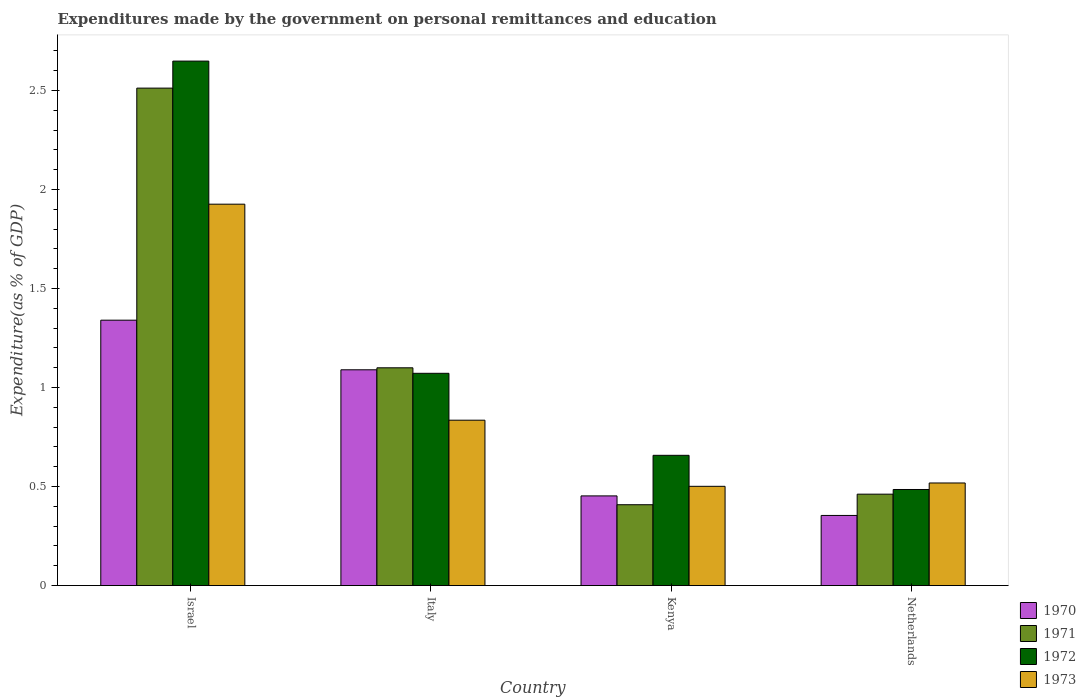How many different coloured bars are there?
Provide a succinct answer. 4. How many groups of bars are there?
Offer a terse response. 4. What is the label of the 3rd group of bars from the left?
Your answer should be very brief. Kenya. In how many cases, is the number of bars for a given country not equal to the number of legend labels?
Make the answer very short. 0. What is the expenditures made by the government on personal remittances and education in 1971 in Israel?
Offer a terse response. 2.51. Across all countries, what is the maximum expenditures made by the government on personal remittances and education in 1973?
Provide a succinct answer. 1.93. Across all countries, what is the minimum expenditures made by the government on personal remittances and education in 1971?
Keep it short and to the point. 0.41. In which country was the expenditures made by the government on personal remittances and education in 1972 minimum?
Make the answer very short. Netherlands. What is the total expenditures made by the government on personal remittances and education in 1971 in the graph?
Offer a terse response. 4.48. What is the difference between the expenditures made by the government on personal remittances and education in 1973 in Kenya and that in Netherlands?
Your answer should be very brief. -0.02. What is the difference between the expenditures made by the government on personal remittances and education in 1971 in Kenya and the expenditures made by the government on personal remittances and education in 1973 in Israel?
Keep it short and to the point. -1.52. What is the average expenditures made by the government on personal remittances and education in 1970 per country?
Give a very brief answer. 0.81. What is the difference between the expenditures made by the government on personal remittances and education of/in 1973 and expenditures made by the government on personal remittances and education of/in 1972 in Italy?
Your response must be concise. -0.24. In how many countries, is the expenditures made by the government on personal remittances and education in 1971 greater than 2.6 %?
Make the answer very short. 0. What is the ratio of the expenditures made by the government on personal remittances and education in 1970 in Italy to that in Kenya?
Offer a very short reply. 2.41. Is the expenditures made by the government on personal remittances and education in 1973 in Italy less than that in Kenya?
Offer a terse response. No. What is the difference between the highest and the second highest expenditures made by the government on personal remittances and education in 1972?
Your answer should be very brief. -0.41. What is the difference between the highest and the lowest expenditures made by the government on personal remittances and education in 1972?
Offer a very short reply. 2.16. Is it the case that in every country, the sum of the expenditures made by the government on personal remittances and education in 1972 and expenditures made by the government on personal remittances and education in 1971 is greater than the sum of expenditures made by the government on personal remittances and education in 1970 and expenditures made by the government on personal remittances and education in 1973?
Your answer should be compact. No. What does the 3rd bar from the left in Italy represents?
Give a very brief answer. 1972. What does the 4th bar from the right in Netherlands represents?
Provide a short and direct response. 1970. Is it the case that in every country, the sum of the expenditures made by the government on personal remittances and education in 1972 and expenditures made by the government on personal remittances and education in 1973 is greater than the expenditures made by the government on personal remittances and education in 1971?
Make the answer very short. Yes. Are all the bars in the graph horizontal?
Your answer should be compact. No. What is the difference between two consecutive major ticks on the Y-axis?
Provide a short and direct response. 0.5. Does the graph contain any zero values?
Your answer should be compact. No. Does the graph contain grids?
Give a very brief answer. No. Where does the legend appear in the graph?
Provide a short and direct response. Bottom right. How many legend labels are there?
Make the answer very short. 4. How are the legend labels stacked?
Provide a succinct answer. Vertical. What is the title of the graph?
Make the answer very short. Expenditures made by the government on personal remittances and education. Does "1984" appear as one of the legend labels in the graph?
Provide a succinct answer. No. What is the label or title of the X-axis?
Offer a very short reply. Country. What is the label or title of the Y-axis?
Provide a succinct answer. Expenditure(as % of GDP). What is the Expenditure(as % of GDP) of 1970 in Israel?
Offer a terse response. 1.34. What is the Expenditure(as % of GDP) in 1971 in Israel?
Provide a succinct answer. 2.51. What is the Expenditure(as % of GDP) of 1972 in Israel?
Offer a very short reply. 2.65. What is the Expenditure(as % of GDP) in 1973 in Israel?
Ensure brevity in your answer.  1.93. What is the Expenditure(as % of GDP) of 1970 in Italy?
Make the answer very short. 1.09. What is the Expenditure(as % of GDP) in 1971 in Italy?
Keep it short and to the point. 1.1. What is the Expenditure(as % of GDP) of 1972 in Italy?
Give a very brief answer. 1.07. What is the Expenditure(as % of GDP) of 1973 in Italy?
Ensure brevity in your answer.  0.84. What is the Expenditure(as % of GDP) in 1970 in Kenya?
Keep it short and to the point. 0.45. What is the Expenditure(as % of GDP) of 1971 in Kenya?
Offer a terse response. 0.41. What is the Expenditure(as % of GDP) in 1972 in Kenya?
Provide a short and direct response. 0.66. What is the Expenditure(as % of GDP) in 1973 in Kenya?
Provide a succinct answer. 0.5. What is the Expenditure(as % of GDP) in 1970 in Netherlands?
Make the answer very short. 0.35. What is the Expenditure(as % of GDP) in 1971 in Netherlands?
Keep it short and to the point. 0.46. What is the Expenditure(as % of GDP) in 1972 in Netherlands?
Ensure brevity in your answer.  0.49. What is the Expenditure(as % of GDP) of 1973 in Netherlands?
Provide a succinct answer. 0.52. Across all countries, what is the maximum Expenditure(as % of GDP) of 1970?
Offer a terse response. 1.34. Across all countries, what is the maximum Expenditure(as % of GDP) in 1971?
Offer a very short reply. 2.51. Across all countries, what is the maximum Expenditure(as % of GDP) of 1972?
Your response must be concise. 2.65. Across all countries, what is the maximum Expenditure(as % of GDP) of 1973?
Ensure brevity in your answer.  1.93. Across all countries, what is the minimum Expenditure(as % of GDP) of 1970?
Provide a short and direct response. 0.35. Across all countries, what is the minimum Expenditure(as % of GDP) of 1971?
Ensure brevity in your answer.  0.41. Across all countries, what is the minimum Expenditure(as % of GDP) of 1972?
Your answer should be compact. 0.49. Across all countries, what is the minimum Expenditure(as % of GDP) of 1973?
Keep it short and to the point. 0.5. What is the total Expenditure(as % of GDP) in 1970 in the graph?
Keep it short and to the point. 3.24. What is the total Expenditure(as % of GDP) in 1971 in the graph?
Offer a terse response. 4.48. What is the total Expenditure(as % of GDP) of 1972 in the graph?
Your response must be concise. 4.86. What is the total Expenditure(as % of GDP) in 1973 in the graph?
Provide a short and direct response. 3.78. What is the difference between the Expenditure(as % of GDP) of 1970 in Israel and that in Italy?
Offer a terse response. 0.25. What is the difference between the Expenditure(as % of GDP) of 1971 in Israel and that in Italy?
Offer a terse response. 1.41. What is the difference between the Expenditure(as % of GDP) of 1972 in Israel and that in Italy?
Your answer should be compact. 1.58. What is the difference between the Expenditure(as % of GDP) in 1970 in Israel and that in Kenya?
Offer a very short reply. 0.89. What is the difference between the Expenditure(as % of GDP) in 1971 in Israel and that in Kenya?
Give a very brief answer. 2.1. What is the difference between the Expenditure(as % of GDP) in 1972 in Israel and that in Kenya?
Your response must be concise. 1.99. What is the difference between the Expenditure(as % of GDP) of 1973 in Israel and that in Kenya?
Ensure brevity in your answer.  1.42. What is the difference between the Expenditure(as % of GDP) of 1970 in Israel and that in Netherlands?
Ensure brevity in your answer.  0.99. What is the difference between the Expenditure(as % of GDP) in 1971 in Israel and that in Netherlands?
Give a very brief answer. 2.05. What is the difference between the Expenditure(as % of GDP) of 1972 in Israel and that in Netherlands?
Offer a very short reply. 2.16. What is the difference between the Expenditure(as % of GDP) of 1973 in Israel and that in Netherlands?
Offer a very short reply. 1.41. What is the difference between the Expenditure(as % of GDP) of 1970 in Italy and that in Kenya?
Offer a terse response. 0.64. What is the difference between the Expenditure(as % of GDP) of 1971 in Italy and that in Kenya?
Offer a very short reply. 0.69. What is the difference between the Expenditure(as % of GDP) in 1972 in Italy and that in Kenya?
Keep it short and to the point. 0.41. What is the difference between the Expenditure(as % of GDP) in 1973 in Italy and that in Kenya?
Offer a very short reply. 0.33. What is the difference between the Expenditure(as % of GDP) in 1970 in Italy and that in Netherlands?
Offer a terse response. 0.74. What is the difference between the Expenditure(as % of GDP) of 1971 in Italy and that in Netherlands?
Provide a succinct answer. 0.64. What is the difference between the Expenditure(as % of GDP) of 1972 in Italy and that in Netherlands?
Your response must be concise. 0.59. What is the difference between the Expenditure(as % of GDP) of 1973 in Italy and that in Netherlands?
Ensure brevity in your answer.  0.32. What is the difference between the Expenditure(as % of GDP) in 1970 in Kenya and that in Netherlands?
Your response must be concise. 0.1. What is the difference between the Expenditure(as % of GDP) in 1971 in Kenya and that in Netherlands?
Offer a very short reply. -0.05. What is the difference between the Expenditure(as % of GDP) in 1972 in Kenya and that in Netherlands?
Keep it short and to the point. 0.17. What is the difference between the Expenditure(as % of GDP) of 1973 in Kenya and that in Netherlands?
Give a very brief answer. -0.02. What is the difference between the Expenditure(as % of GDP) of 1970 in Israel and the Expenditure(as % of GDP) of 1971 in Italy?
Make the answer very short. 0.24. What is the difference between the Expenditure(as % of GDP) of 1970 in Israel and the Expenditure(as % of GDP) of 1972 in Italy?
Make the answer very short. 0.27. What is the difference between the Expenditure(as % of GDP) of 1970 in Israel and the Expenditure(as % of GDP) of 1973 in Italy?
Offer a very short reply. 0.51. What is the difference between the Expenditure(as % of GDP) in 1971 in Israel and the Expenditure(as % of GDP) in 1972 in Italy?
Your answer should be compact. 1.44. What is the difference between the Expenditure(as % of GDP) of 1971 in Israel and the Expenditure(as % of GDP) of 1973 in Italy?
Offer a very short reply. 1.68. What is the difference between the Expenditure(as % of GDP) of 1972 in Israel and the Expenditure(as % of GDP) of 1973 in Italy?
Give a very brief answer. 1.81. What is the difference between the Expenditure(as % of GDP) in 1970 in Israel and the Expenditure(as % of GDP) in 1971 in Kenya?
Offer a very short reply. 0.93. What is the difference between the Expenditure(as % of GDP) in 1970 in Israel and the Expenditure(as % of GDP) in 1972 in Kenya?
Keep it short and to the point. 0.68. What is the difference between the Expenditure(as % of GDP) in 1970 in Israel and the Expenditure(as % of GDP) in 1973 in Kenya?
Provide a short and direct response. 0.84. What is the difference between the Expenditure(as % of GDP) of 1971 in Israel and the Expenditure(as % of GDP) of 1972 in Kenya?
Provide a succinct answer. 1.85. What is the difference between the Expenditure(as % of GDP) of 1971 in Israel and the Expenditure(as % of GDP) of 1973 in Kenya?
Your response must be concise. 2.01. What is the difference between the Expenditure(as % of GDP) of 1972 in Israel and the Expenditure(as % of GDP) of 1973 in Kenya?
Provide a short and direct response. 2.15. What is the difference between the Expenditure(as % of GDP) of 1970 in Israel and the Expenditure(as % of GDP) of 1971 in Netherlands?
Provide a succinct answer. 0.88. What is the difference between the Expenditure(as % of GDP) in 1970 in Israel and the Expenditure(as % of GDP) in 1972 in Netherlands?
Make the answer very short. 0.85. What is the difference between the Expenditure(as % of GDP) of 1970 in Israel and the Expenditure(as % of GDP) of 1973 in Netherlands?
Offer a terse response. 0.82. What is the difference between the Expenditure(as % of GDP) in 1971 in Israel and the Expenditure(as % of GDP) in 1972 in Netherlands?
Offer a very short reply. 2.03. What is the difference between the Expenditure(as % of GDP) of 1971 in Israel and the Expenditure(as % of GDP) of 1973 in Netherlands?
Offer a terse response. 1.99. What is the difference between the Expenditure(as % of GDP) in 1972 in Israel and the Expenditure(as % of GDP) in 1973 in Netherlands?
Offer a terse response. 2.13. What is the difference between the Expenditure(as % of GDP) in 1970 in Italy and the Expenditure(as % of GDP) in 1971 in Kenya?
Provide a succinct answer. 0.68. What is the difference between the Expenditure(as % of GDP) in 1970 in Italy and the Expenditure(as % of GDP) in 1972 in Kenya?
Keep it short and to the point. 0.43. What is the difference between the Expenditure(as % of GDP) of 1970 in Italy and the Expenditure(as % of GDP) of 1973 in Kenya?
Your answer should be very brief. 0.59. What is the difference between the Expenditure(as % of GDP) in 1971 in Italy and the Expenditure(as % of GDP) in 1972 in Kenya?
Offer a very short reply. 0.44. What is the difference between the Expenditure(as % of GDP) of 1971 in Italy and the Expenditure(as % of GDP) of 1973 in Kenya?
Ensure brevity in your answer.  0.6. What is the difference between the Expenditure(as % of GDP) of 1972 in Italy and the Expenditure(as % of GDP) of 1973 in Kenya?
Give a very brief answer. 0.57. What is the difference between the Expenditure(as % of GDP) of 1970 in Italy and the Expenditure(as % of GDP) of 1971 in Netherlands?
Ensure brevity in your answer.  0.63. What is the difference between the Expenditure(as % of GDP) of 1970 in Italy and the Expenditure(as % of GDP) of 1972 in Netherlands?
Provide a short and direct response. 0.6. What is the difference between the Expenditure(as % of GDP) of 1970 in Italy and the Expenditure(as % of GDP) of 1973 in Netherlands?
Make the answer very short. 0.57. What is the difference between the Expenditure(as % of GDP) of 1971 in Italy and the Expenditure(as % of GDP) of 1972 in Netherlands?
Keep it short and to the point. 0.61. What is the difference between the Expenditure(as % of GDP) of 1971 in Italy and the Expenditure(as % of GDP) of 1973 in Netherlands?
Give a very brief answer. 0.58. What is the difference between the Expenditure(as % of GDP) in 1972 in Italy and the Expenditure(as % of GDP) in 1973 in Netherlands?
Give a very brief answer. 0.55. What is the difference between the Expenditure(as % of GDP) of 1970 in Kenya and the Expenditure(as % of GDP) of 1971 in Netherlands?
Provide a succinct answer. -0.01. What is the difference between the Expenditure(as % of GDP) of 1970 in Kenya and the Expenditure(as % of GDP) of 1972 in Netherlands?
Give a very brief answer. -0.03. What is the difference between the Expenditure(as % of GDP) of 1970 in Kenya and the Expenditure(as % of GDP) of 1973 in Netherlands?
Your answer should be very brief. -0.07. What is the difference between the Expenditure(as % of GDP) of 1971 in Kenya and the Expenditure(as % of GDP) of 1972 in Netherlands?
Offer a very short reply. -0.08. What is the difference between the Expenditure(as % of GDP) in 1971 in Kenya and the Expenditure(as % of GDP) in 1973 in Netherlands?
Your answer should be very brief. -0.11. What is the difference between the Expenditure(as % of GDP) in 1972 in Kenya and the Expenditure(as % of GDP) in 1973 in Netherlands?
Your response must be concise. 0.14. What is the average Expenditure(as % of GDP) in 1970 per country?
Make the answer very short. 0.81. What is the average Expenditure(as % of GDP) in 1971 per country?
Provide a succinct answer. 1.12. What is the average Expenditure(as % of GDP) in 1972 per country?
Give a very brief answer. 1.22. What is the average Expenditure(as % of GDP) of 1973 per country?
Offer a terse response. 0.95. What is the difference between the Expenditure(as % of GDP) of 1970 and Expenditure(as % of GDP) of 1971 in Israel?
Your answer should be compact. -1.17. What is the difference between the Expenditure(as % of GDP) of 1970 and Expenditure(as % of GDP) of 1972 in Israel?
Offer a terse response. -1.31. What is the difference between the Expenditure(as % of GDP) of 1970 and Expenditure(as % of GDP) of 1973 in Israel?
Your response must be concise. -0.59. What is the difference between the Expenditure(as % of GDP) of 1971 and Expenditure(as % of GDP) of 1972 in Israel?
Offer a very short reply. -0.14. What is the difference between the Expenditure(as % of GDP) in 1971 and Expenditure(as % of GDP) in 1973 in Israel?
Give a very brief answer. 0.59. What is the difference between the Expenditure(as % of GDP) in 1972 and Expenditure(as % of GDP) in 1973 in Israel?
Offer a terse response. 0.72. What is the difference between the Expenditure(as % of GDP) of 1970 and Expenditure(as % of GDP) of 1971 in Italy?
Provide a succinct answer. -0.01. What is the difference between the Expenditure(as % of GDP) of 1970 and Expenditure(as % of GDP) of 1972 in Italy?
Give a very brief answer. 0.02. What is the difference between the Expenditure(as % of GDP) in 1970 and Expenditure(as % of GDP) in 1973 in Italy?
Give a very brief answer. 0.25. What is the difference between the Expenditure(as % of GDP) of 1971 and Expenditure(as % of GDP) of 1972 in Italy?
Your answer should be very brief. 0.03. What is the difference between the Expenditure(as % of GDP) of 1971 and Expenditure(as % of GDP) of 1973 in Italy?
Offer a terse response. 0.26. What is the difference between the Expenditure(as % of GDP) in 1972 and Expenditure(as % of GDP) in 1973 in Italy?
Provide a short and direct response. 0.24. What is the difference between the Expenditure(as % of GDP) of 1970 and Expenditure(as % of GDP) of 1971 in Kenya?
Offer a very short reply. 0.04. What is the difference between the Expenditure(as % of GDP) of 1970 and Expenditure(as % of GDP) of 1972 in Kenya?
Offer a terse response. -0.2. What is the difference between the Expenditure(as % of GDP) in 1970 and Expenditure(as % of GDP) in 1973 in Kenya?
Offer a very short reply. -0.05. What is the difference between the Expenditure(as % of GDP) in 1971 and Expenditure(as % of GDP) in 1972 in Kenya?
Offer a very short reply. -0.25. What is the difference between the Expenditure(as % of GDP) of 1971 and Expenditure(as % of GDP) of 1973 in Kenya?
Your answer should be compact. -0.09. What is the difference between the Expenditure(as % of GDP) of 1972 and Expenditure(as % of GDP) of 1973 in Kenya?
Make the answer very short. 0.16. What is the difference between the Expenditure(as % of GDP) of 1970 and Expenditure(as % of GDP) of 1971 in Netherlands?
Your response must be concise. -0.11. What is the difference between the Expenditure(as % of GDP) of 1970 and Expenditure(as % of GDP) of 1972 in Netherlands?
Provide a short and direct response. -0.13. What is the difference between the Expenditure(as % of GDP) in 1970 and Expenditure(as % of GDP) in 1973 in Netherlands?
Offer a terse response. -0.16. What is the difference between the Expenditure(as % of GDP) in 1971 and Expenditure(as % of GDP) in 1972 in Netherlands?
Your answer should be very brief. -0.02. What is the difference between the Expenditure(as % of GDP) in 1971 and Expenditure(as % of GDP) in 1973 in Netherlands?
Make the answer very short. -0.06. What is the difference between the Expenditure(as % of GDP) of 1972 and Expenditure(as % of GDP) of 1973 in Netherlands?
Keep it short and to the point. -0.03. What is the ratio of the Expenditure(as % of GDP) in 1970 in Israel to that in Italy?
Your answer should be very brief. 1.23. What is the ratio of the Expenditure(as % of GDP) of 1971 in Israel to that in Italy?
Offer a very short reply. 2.28. What is the ratio of the Expenditure(as % of GDP) of 1972 in Israel to that in Italy?
Your response must be concise. 2.47. What is the ratio of the Expenditure(as % of GDP) of 1973 in Israel to that in Italy?
Provide a short and direct response. 2.31. What is the ratio of the Expenditure(as % of GDP) of 1970 in Israel to that in Kenya?
Provide a short and direct response. 2.96. What is the ratio of the Expenditure(as % of GDP) of 1971 in Israel to that in Kenya?
Offer a very short reply. 6.15. What is the ratio of the Expenditure(as % of GDP) of 1972 in Israel to that in Kenya?
Provide a succinct answer. 4.03. What is the ratio of the Expenditure(as % of GDP) in 1973 in Israel to that in Kenya?
Your answer should be compact. 3.84. What is the ratio of the Expenditure(as % of GDP) of 1970 in Israel to that in Netherlands?
Provide a short and direct response. 3.78. What is the ratio of the Expenditure(as % of GDP) of 1971 in Israel to that in Netherlands?
Provide a short and direct response. 5.44. What is the ratio of the Expenditure(as % of GDP) in 1972 in Israel to that in Netherlands?
Offer a very short reply. 5.46. What is the ratio of the Expenditure(as % of GDP) in 1973 in Israel to that in Netherlands?
Keep it short and to the point. 3.72. What is the ratio of the Expenditure(as % of GDP) in 1970 in Italy to that in Kenya?
Offer a very short reply. 2.41. What is the ratio of the Expenditure(as % of GDP) of 1971 in Italy to that in Kenya?
Your answer should be very brief. 2.69. What is the ratio of the Expenditure(as % of GDP) in 1972 in Italy to that in Kenya?
Your answer should be compact. 1.63. What is the ratio of the Expenditure(as % of GDP) in 1973 in Italy to that in Kenya?
Keep it short and to the point. 1.67. What is the ratio of the Expenditure(as % of GDP) of 1970 in Italy to that in Netherlands?
Your answer should be very brief. 3.08. What is the ratio of the Expenditure(as % of GDP) of 1971 in Italy to that in Netherlands?
Keep it short and to the point. 2.38. What is the ratio of the Expenditure(as % of GDP) in 1972 in Italy to that in Netherlands?
Your answer should be very brief. 2.21. What is the ratio of the Expenditure(as % of GDP) of 1973 in Italy to that in Netherlands?
Provide a short and direct response. 1.61. What is the ratio of the Expenditure(as % of GDP) of 1970 in Kenya to that in Netherlands?
Offer a terse response. 1.28. What is the ratio of the Expenditure(as % of GDP) in 1971 in Kenya to that in Netherlands?
Your response must be concise. 0.88. What is the ratio of the Expenditure(as % of GDP) of 1972 in Kenya to that in Netherlands?
Your answer should be very brief. 1.36. What is the ratio of the Expenditure(as % of GDP) of 1973 in Kenya to that in Netherlands?
Make the answer very short. 0.97. What is the difference between the highest and the second highest Expenditure(as % of GDP) in 1970?
Offer a terse response. 0.25. What is the difference between the highest and the second highest Expenditure(as % of GDP) of 1971?
Your response must be concise. 1.41. What is the difference between the highest and the second highest Expenditure(as % of GDP) in 1972?
Your answer should be compact. 1.58. What is the difference between the highest and the lowest Expenditure(as % of GDP) of 1970?
Ensure brevity in your answer.  0.99. What is the difference between the highest and the lowest Expenditure(as % of GDP) of 1971?
Keep it short and to the point. 2.1. What is the difference between the highest and the lowest Expenditure(as % of GDP) in 1972?
Your response must be concise. 2.16. What is the difference between the highest and the lowest Expenditure(as % of GDP) of 1973?
Provide a succinct answer. 1.42. 